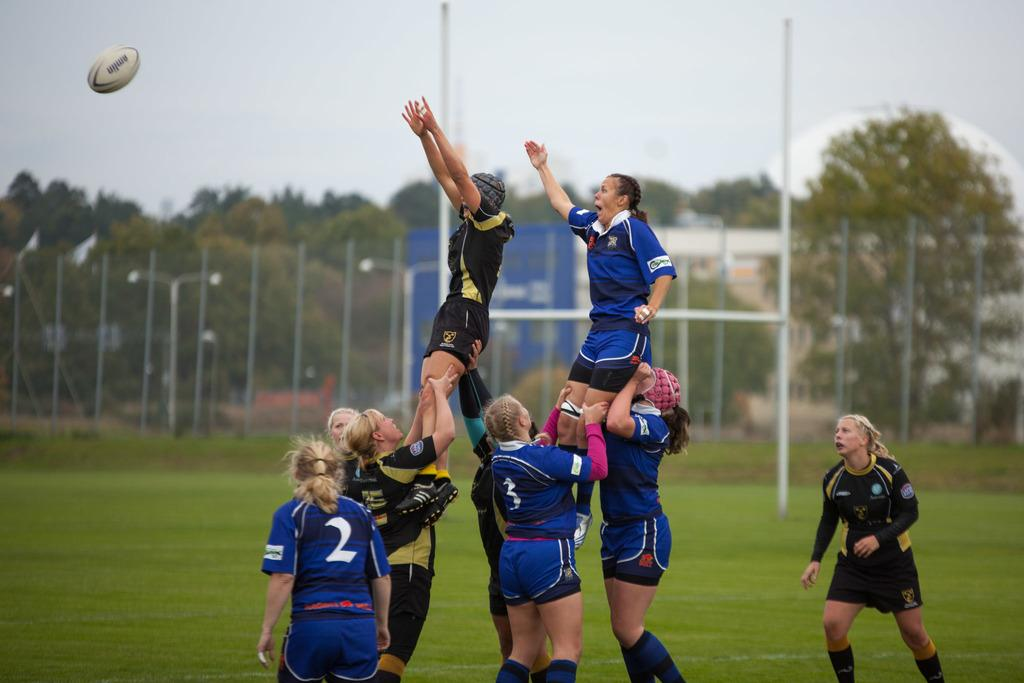<image>
Write a terse but informative summary of the picture. Women playing rugby in full uniforms one player is number two and one is three, two players are being lifted. 